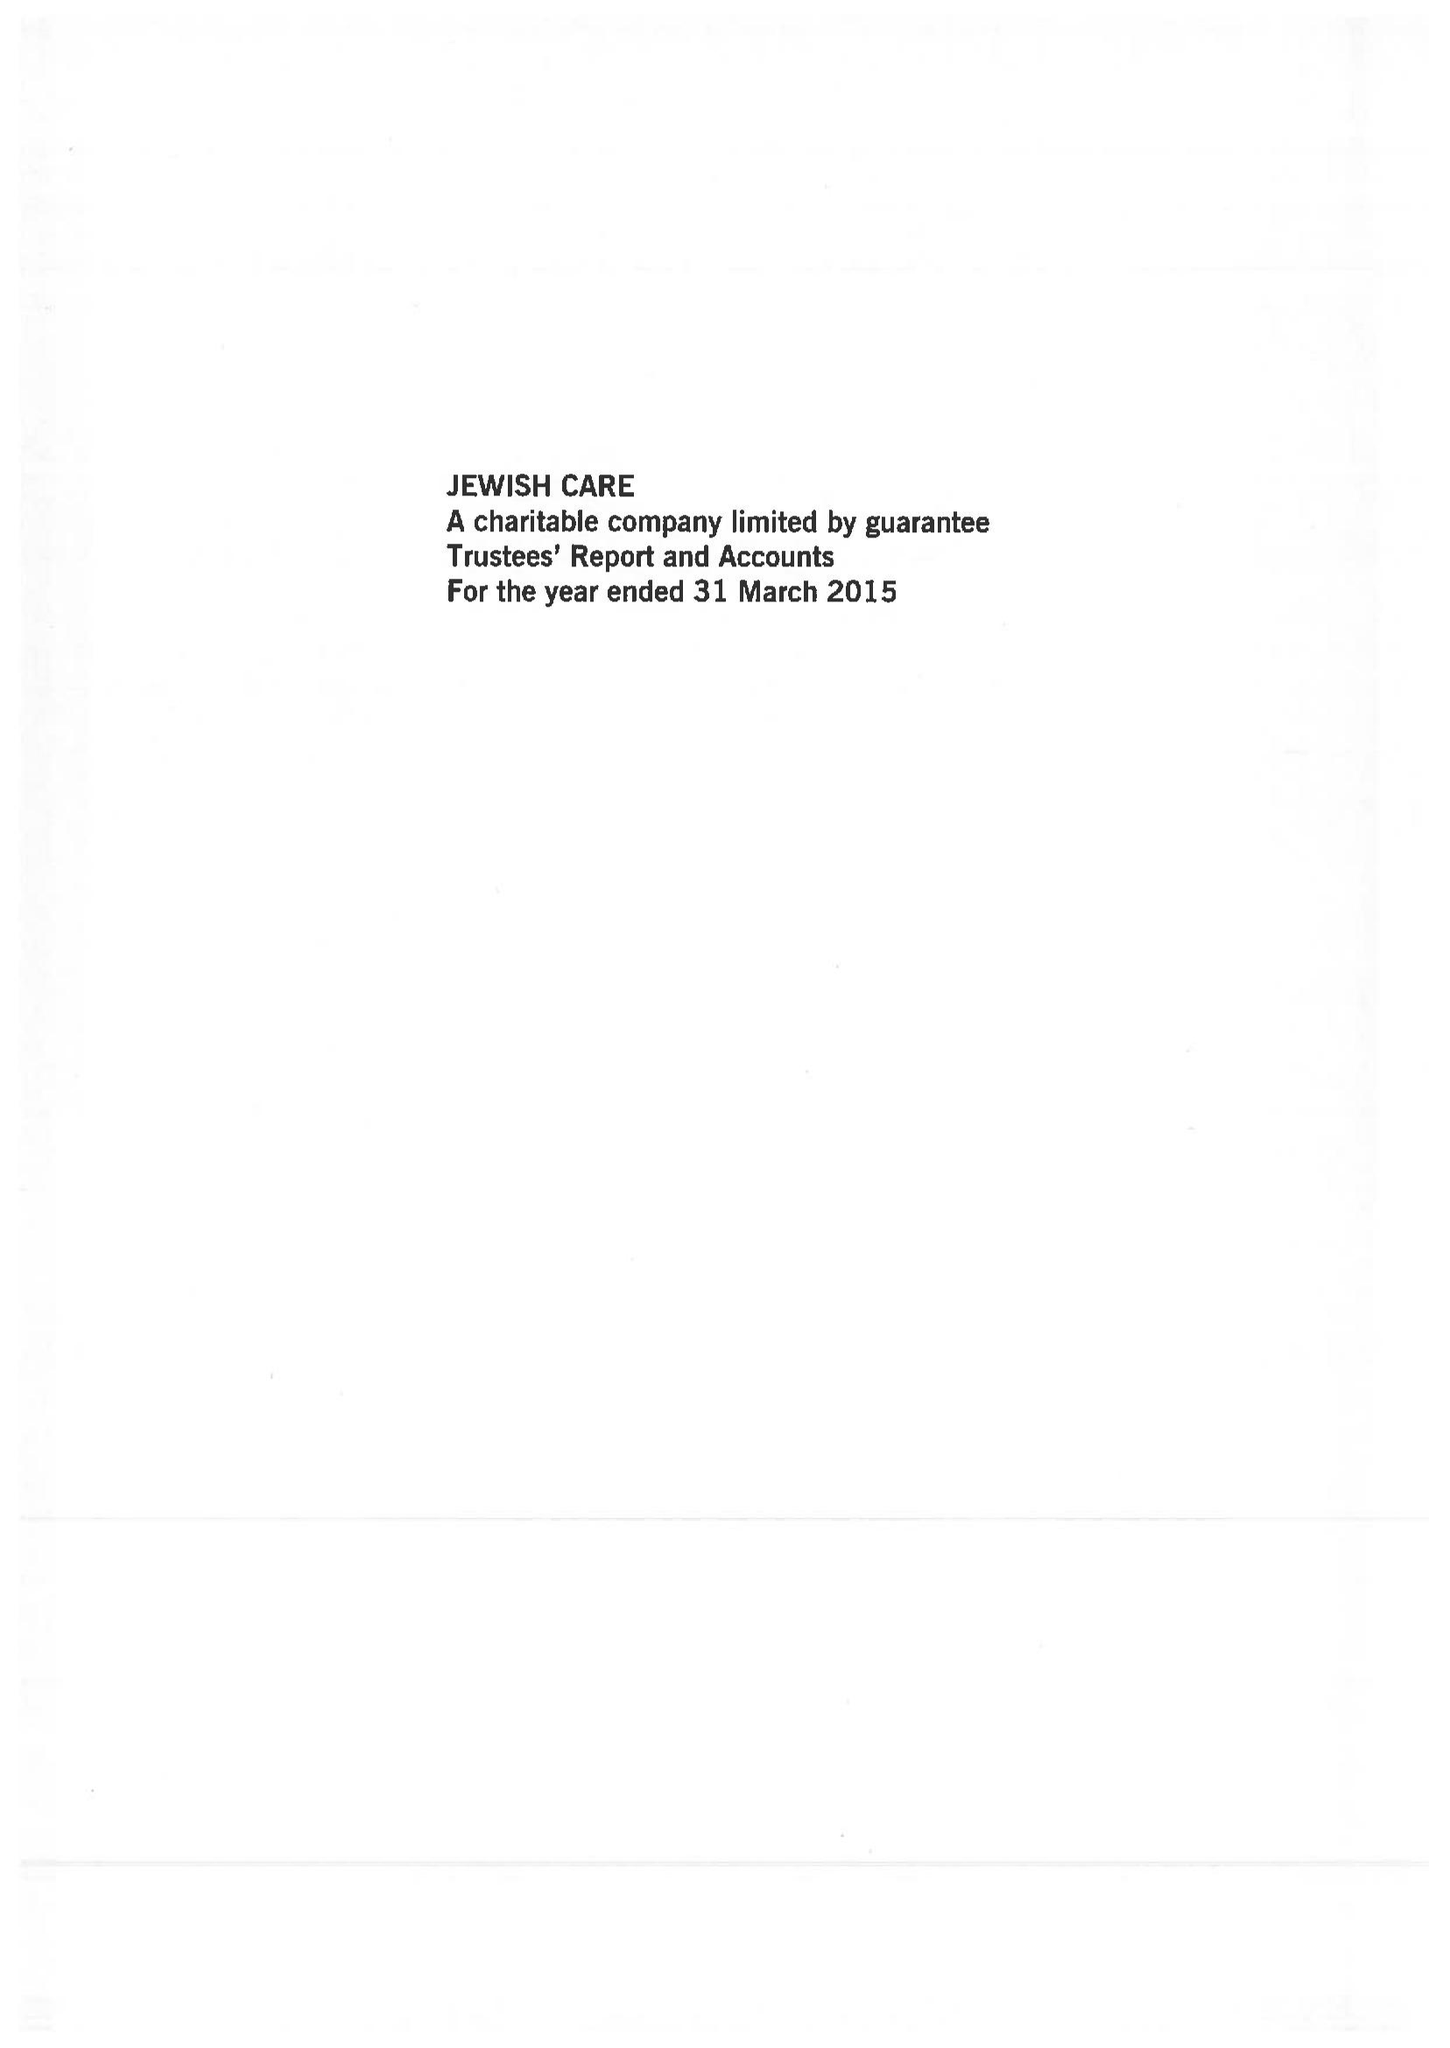What is the value for the spending_annually_in_british_pounds?
Answer the question using a single word or phrase. 49431000.00 